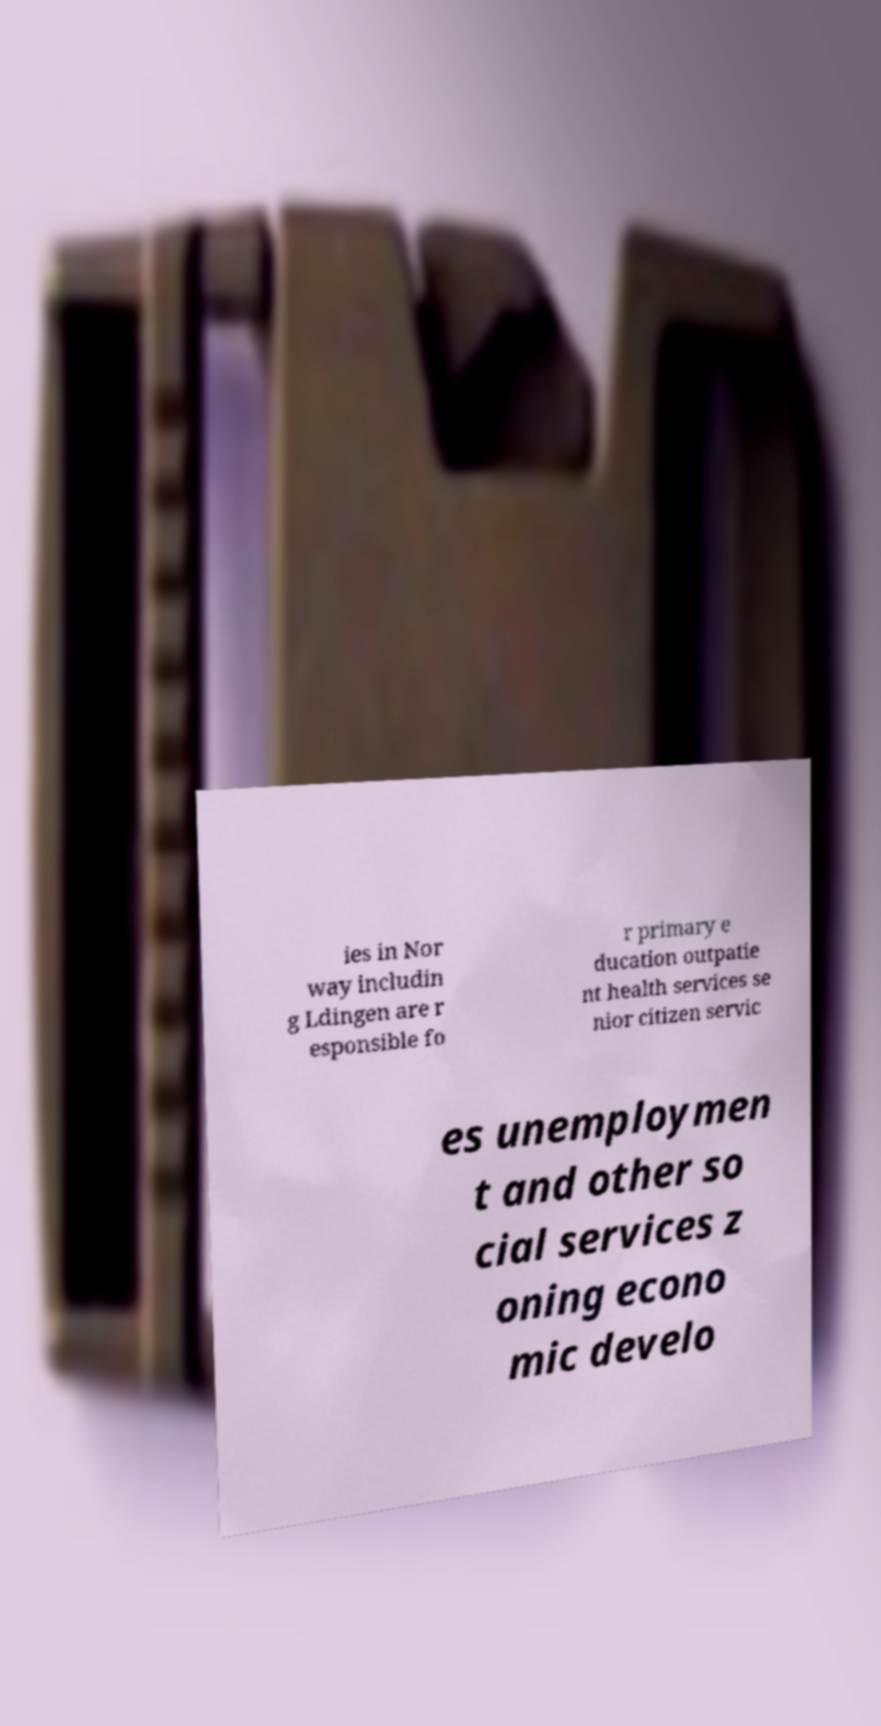Can you read and provide the text displayed in the image?This photo seems to have some interesting text. Can you extract and type it out for me? ies in Nor way includin g Ldingen are r esponsible fo r primary e ducation outpatie nt health services se nior citizen servic es unemploymen t and other so cial services z oning econo mic develo 